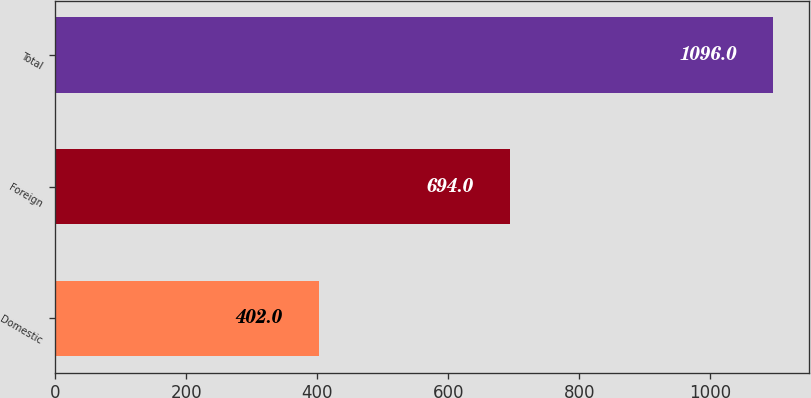<chart> <loc_0><loc_0><loc_500><loc_500><bar_chart><fcel>Domestic<fcel>Foreign<fcel>Total<nl><fcel>402<fcel>694<fcel>1096<nl></chart> 